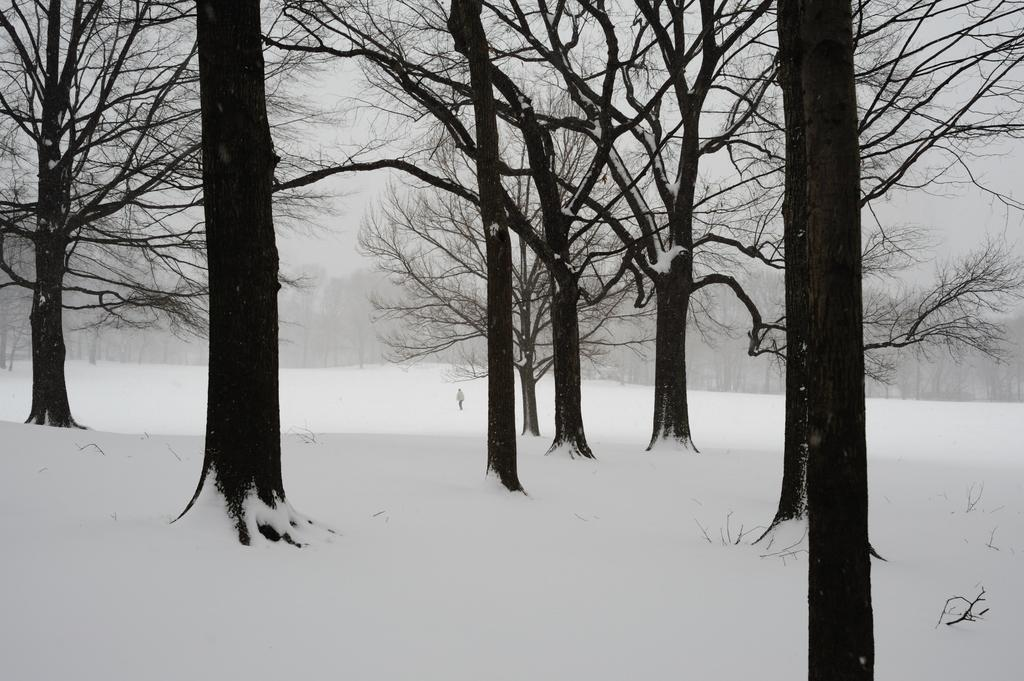Who or what is the main subject in the center of the image? There is a person in the center of the image. What type of terrain is the person standing on? The person is on the snow. What can be seen in the background of the image? There is snow, trees, and the sky visible in the background of the image. What type of pot can be seen in the zoo in the image? There is no pot or zoo visible in the image. 